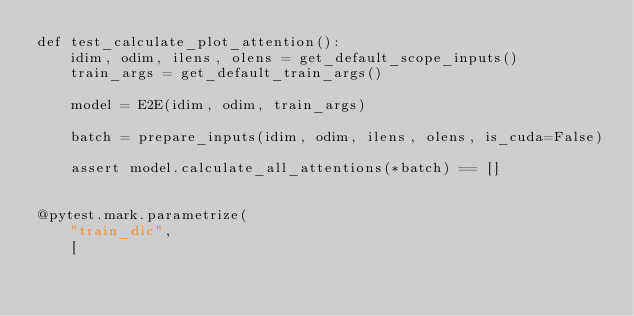<code> <loc_0><loc_0><loc_500><loc_500><_Python_>def test_calculate_plot_attention():
    idim, odim, ilens, olens = get_default_scope_inputs()
    train_args = get_default_train_args()

    model = E2E(idim, odim, train_args)

    batch = prepare_inputs(idim, odim, ilens, olens, is_cuda=False)

    assert model.calculate_all_attentions(*batch) == []


@pytest.mark.parametrize(
    "train_dic",
    [</code> 